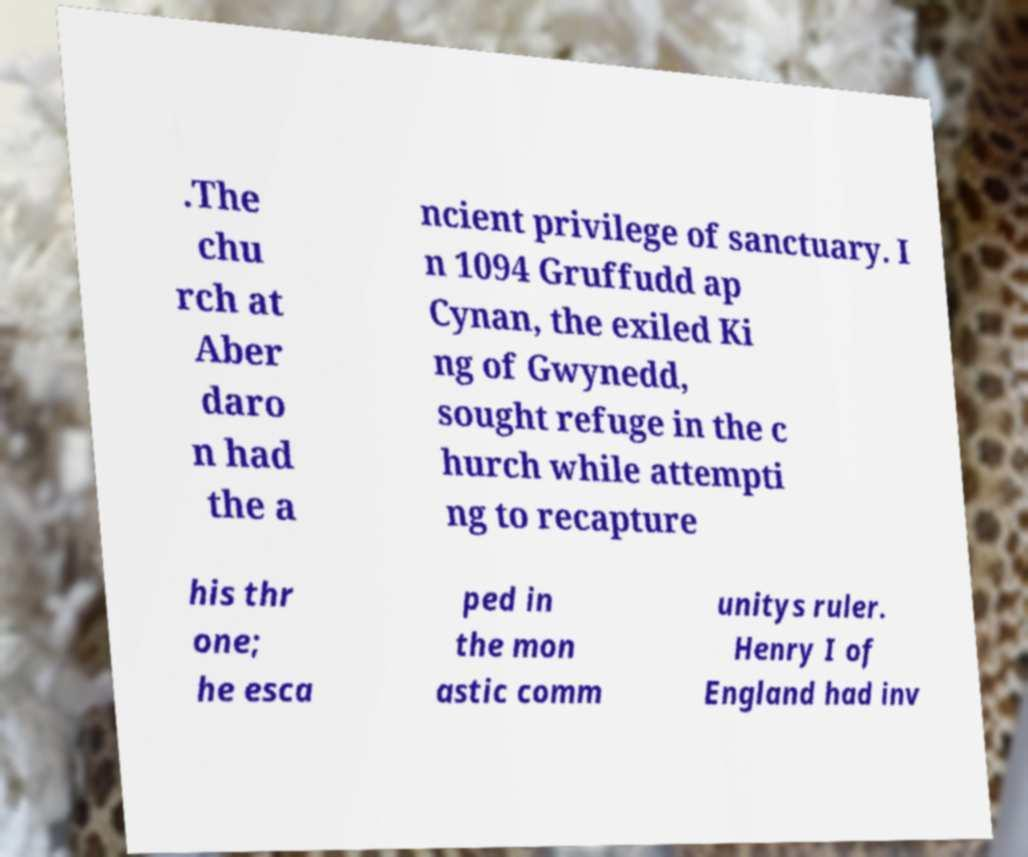Can you read and provide the text displayed in the image?This photo seems to have some interesting text. Can you extract and type it out for me? .The chu rch at Aber daro n had the a ncient privilege of sanctuary. I n 1094 Gruffudd ap Cynan, the exiled Ki ng of Gwynedd, sought refuge in the c hurch while attempti ng to recapture his thr one; he esca ped in the mon astic comm unitys ruler. Henry I of England had inv 